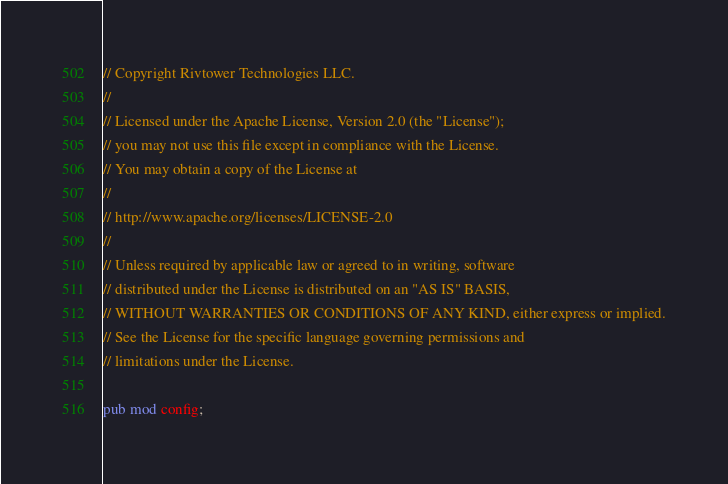<code> <loc_0><loc_0><loc_500><loc_500><_Rust_>// Copyright Rivtower Technologies LLC.
//
// Licensed under the Apache License, Version 2.0 (the "License");
// you may not use this file except in compliance with the License.
// You may obtain a copy of the License at
//
// http://www.apache.org/licenses/LICENSE-2.0
//
// Unless required by applicable law or agreed to in writing, software
// distributed under the License is distributed on an "AS IS" BASIS,
// WITHOUT WARRANTIES OR CONDITIONS OF ANY KIND, either express or implied.
// See the License for the specific language governing permissions and
// limitations under the License.

pub mod config;
</code> 